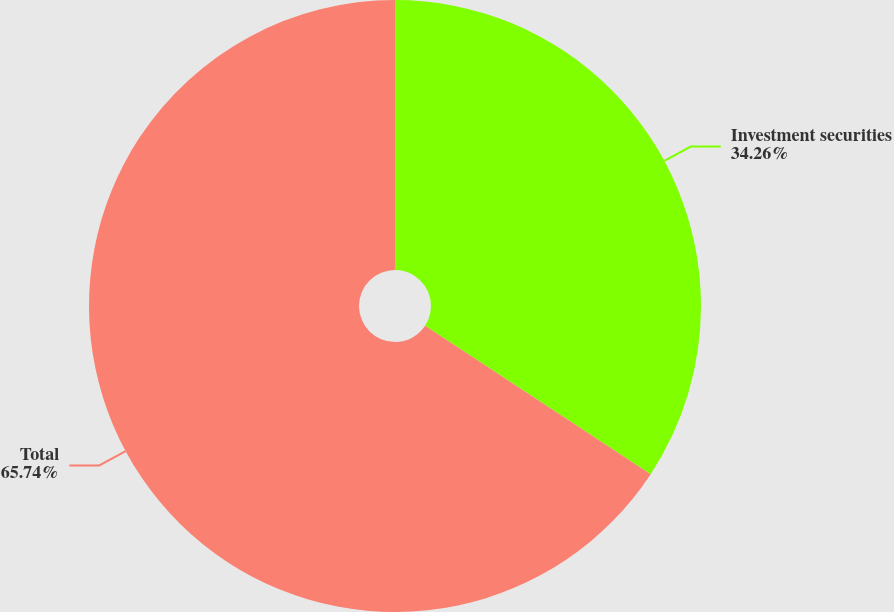Convert chart to OTSL. <chart><loc_0><loc_0><loc_500><loc_500><pie_chart><fcel>Investment securities<fcel>Total<nl><fcel>34.26%<fcel>65.74%<nl></chart> 